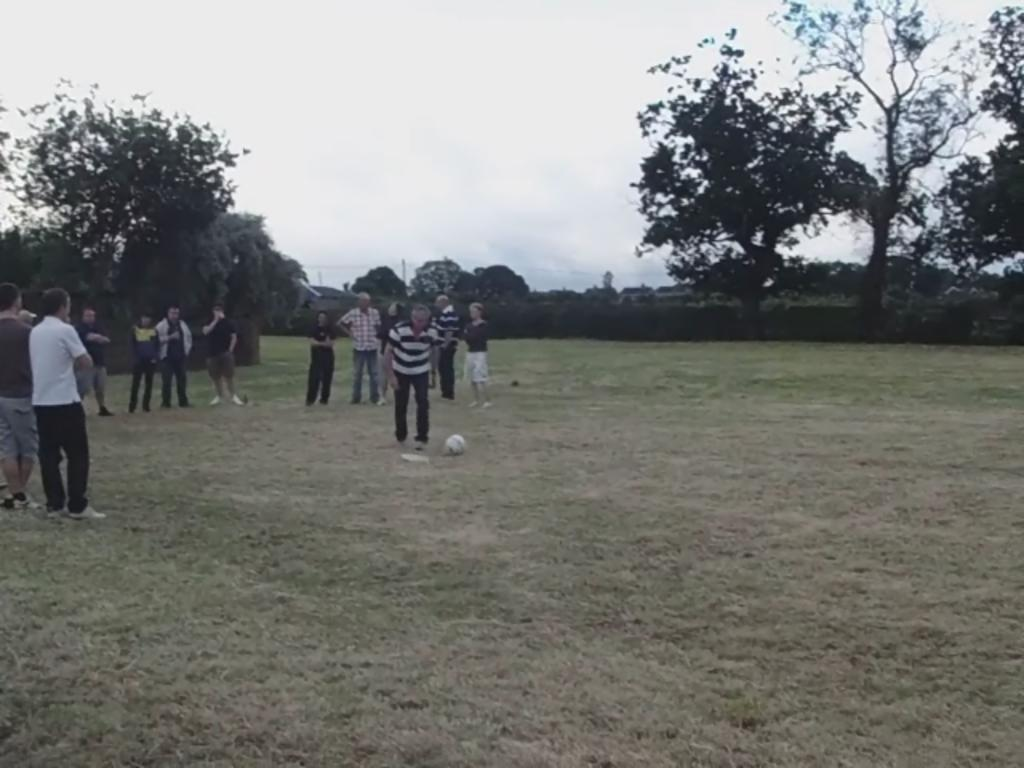What activity are the persons in the image engaged in? The persons in the image are playing football. Where is the football game taking place? The football game is taking place on a ground. What can be seen in the background of the image? There are trees visible in the background of the image. How many potatoes are being used as goalposts in the image? There are no potatoes present in the image, and the goalposts are not made of potatoes. 